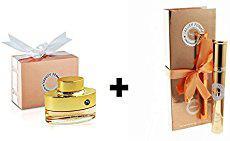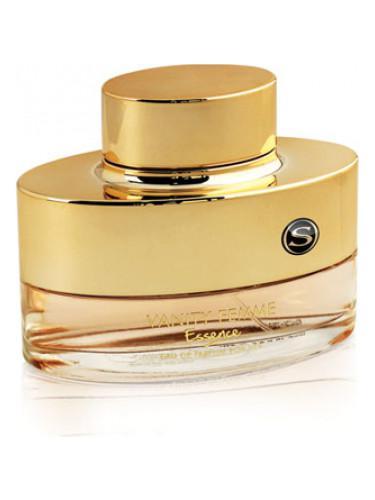The first image is the image on the left, the second image is the image on the right. Evaluate the accuracy of this statement regarding the images: "one of the images contains a cylinder.". Is it true? Answer yes or no. Yes. 